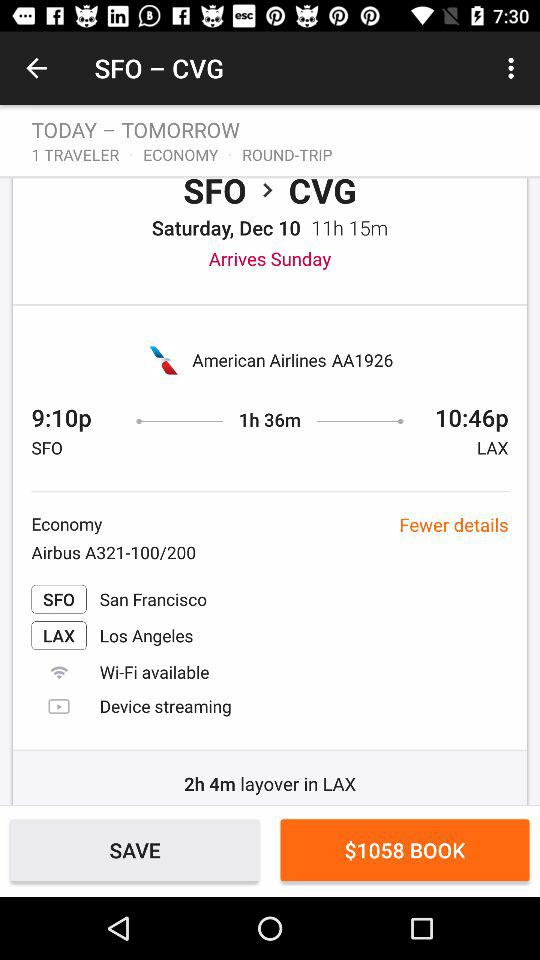What is the name of the city that has the SFO airport? The name of the city is San Francisco. 